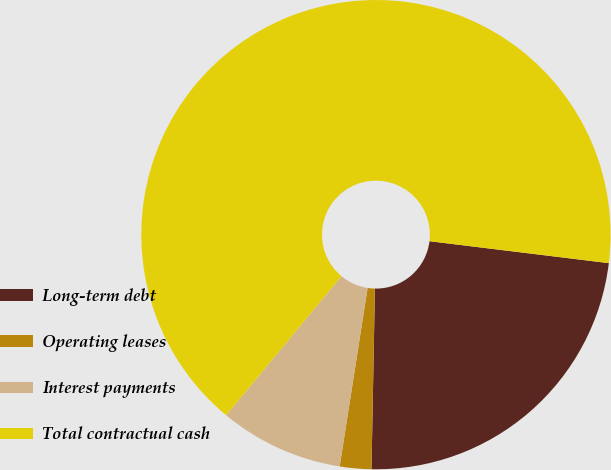Convert chart to OTSL. <chart><loc_0><loc_0><loc_500><loc_500><pie_chart><fcel>Long-term debt<fcel>Operating leases<fcel>Interest payments<fcel>Total contractual cash<nl><fcel>23.36%<fcel>2.17%<fcel>8.55%<fcel>65.91%<nl></chart> 